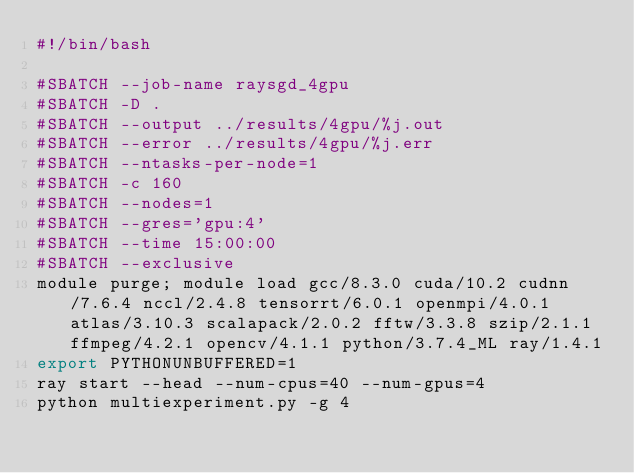Convert code to text. <code><loc_0><loc_0><loc_500><loc_500><_Bash_>#!/bin/bash

#SBATCH --job-name raysgd_4gpu
#SBATCH -D .
#SBATCH --output ../results/4gpu/%j.out
#SBATCH --error ../results/4gpu/%j.err
#SBATCH --ntasks-per-node=1
#SBATCH -c 160
#SBATCH --nodes=1
#SBATCH --gres='gpu:4'
#SBATCH --time 15:00:00
#SBATCH --exclusive
module purge; module load gcc/8.3.0 cuda/10.2 cudnn/7.6.4 nccl/2.4.8 tensorrt/6.0.1 openmpi/4.0.1 atlas/3.10.3 scalapack/2.0.2 fftw/3.3.8 szip/2.1.1 ffmpeg/4.2.1 opencv/4.1.1 python/3.7.4_ML ray/1.4.1
export PYTHONUNBUFFERED=1
ray start --head --num-cpus=40 --num-gpus=4
python multiexperiment.py -g 4
</code> 